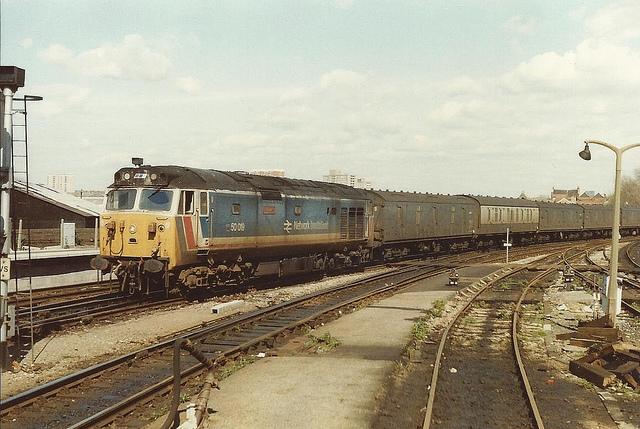Is this a passenger train?
Keep it brief. Yes. What color is the front of the train?
Give a very brief answer. Yellow. Is the train in station?
Quick response, please. No. Is the sky clear?
Keep it brief. No. Is this a freight train?
Concise answer only. Yes. 